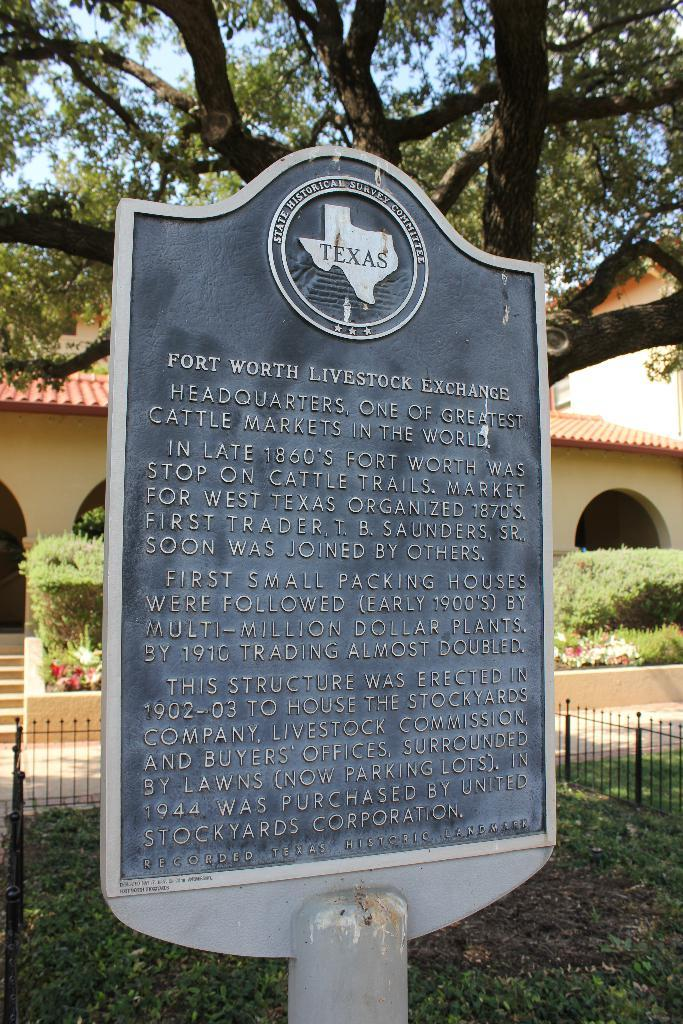What is written or displayed on the board in the image? There is a board with text in the image. What type of structure can be seen in the image? There is a fence, stairs, a building, and an arch in the image. What type of vegetation is present in the image? There is grass, a plant, and a tree in the image. What part of the natural environment is visible in the image? The sky is visible in the image. What type of notebook is being used by the country in the image? There is no mention of a notebook or a country in the image. The image features a board with text, a fence, stairs, a building, an arch, grass, a plant, a tree, and the sky. 